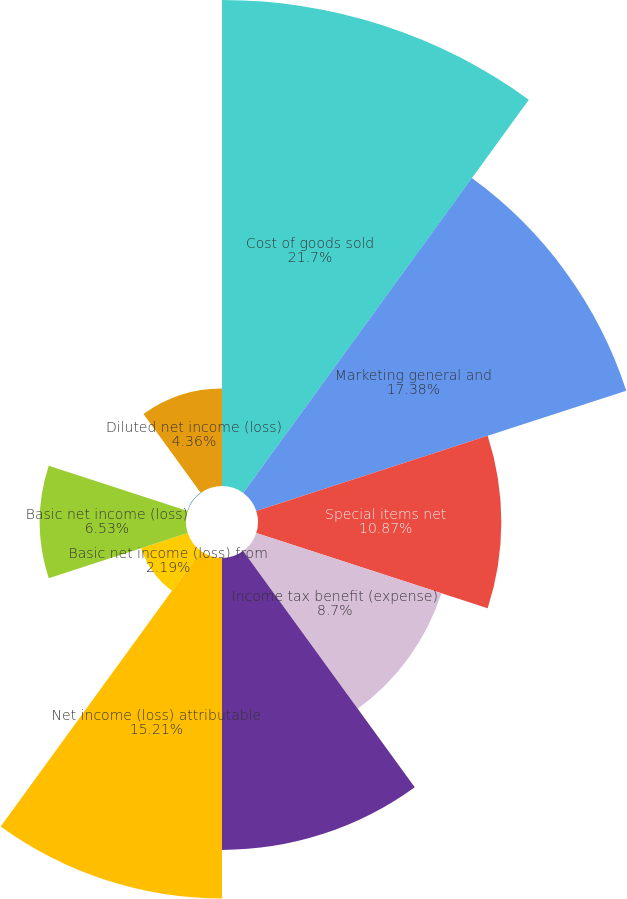Convert chart to OTSL. <chart><loc_0><loc_0><loc_500><loc_500><pie_chart><fcel>Cost of goods sold<fcel>Marketing general and<fcel>Special items net<fcel>Income tax benefit (expense)<fcel>Net income (loss) from<fcel>Net income (loss) attributable<fcel>Basic net income (loss) from<fcel>Basic net income (loss)<fcel>Diluted net income (loss) from<fcel>Diluted net income (loss)<nl><fcel>21.71%<fcel>17.38%<fcel>10.87%<fcel>8.7%<fcel>13.04%<fcel>15.21%<fcel>2.19%<fcel>6.53%<fcel>0.02%<fcel>4.36%<nl></chart> 